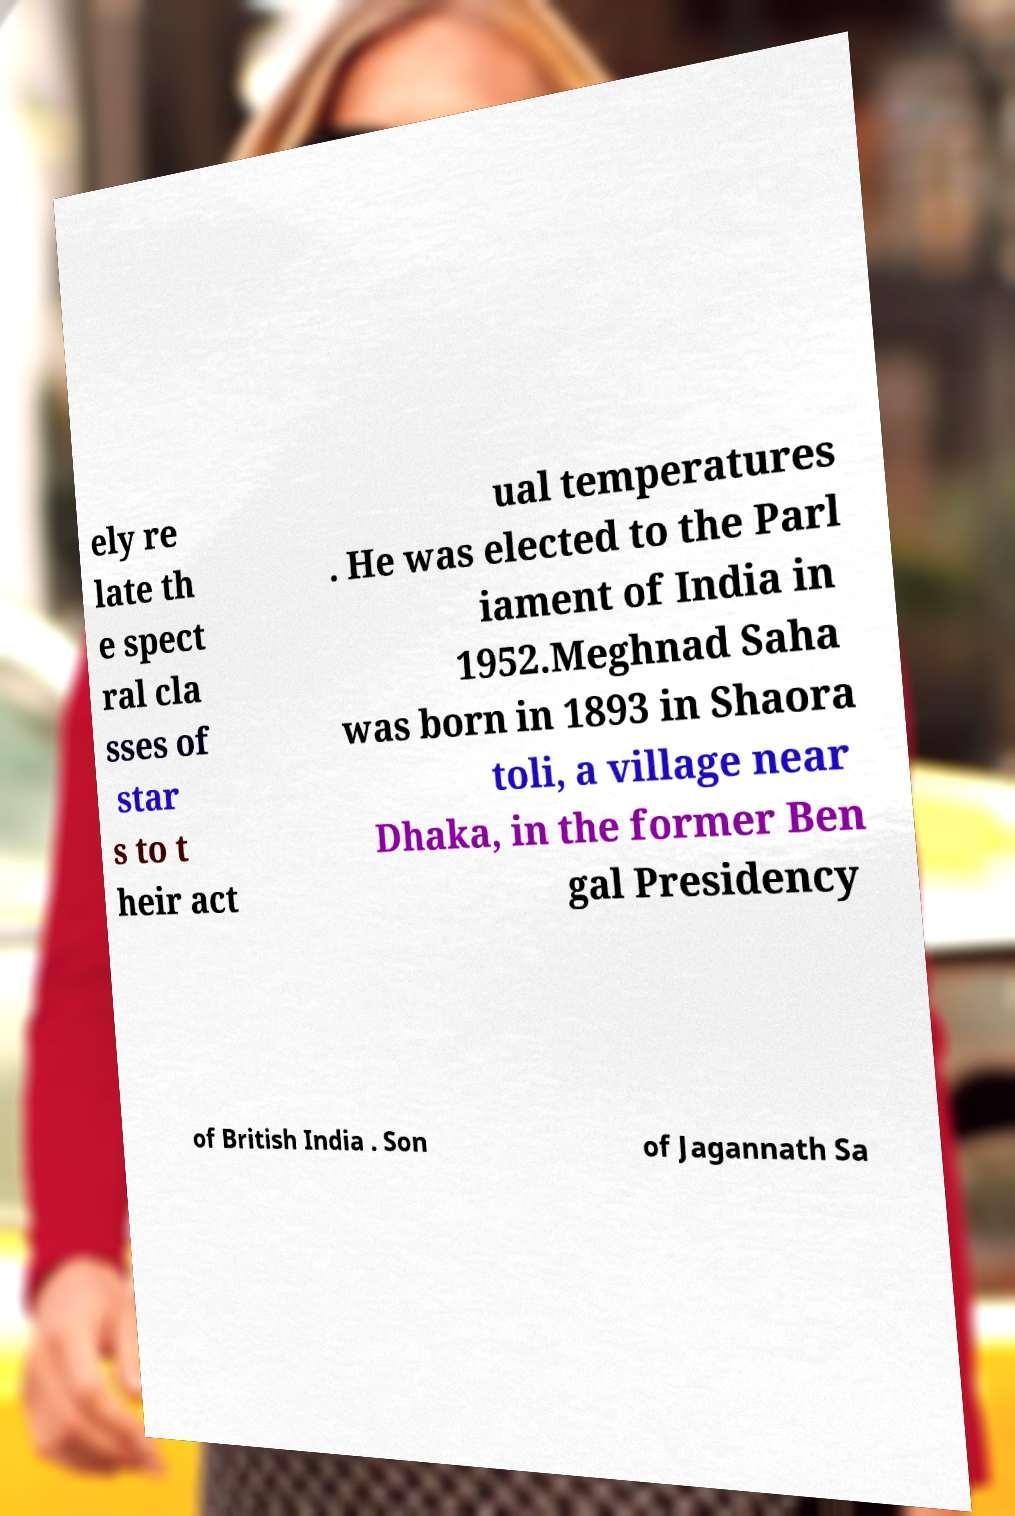There's text embedded in this image that I need extracted. Can you transcribe it verbatim? ely re late th e spect ral cla sses of star s to t heir act ual temperatures . He was elected to the Parl iament of India in 1952.Meghnad Saha was born in 1893 in Shaora toli, a village near Dhaka, in the former Ben gal Presidency of British India . Son of Jagannath Sa 